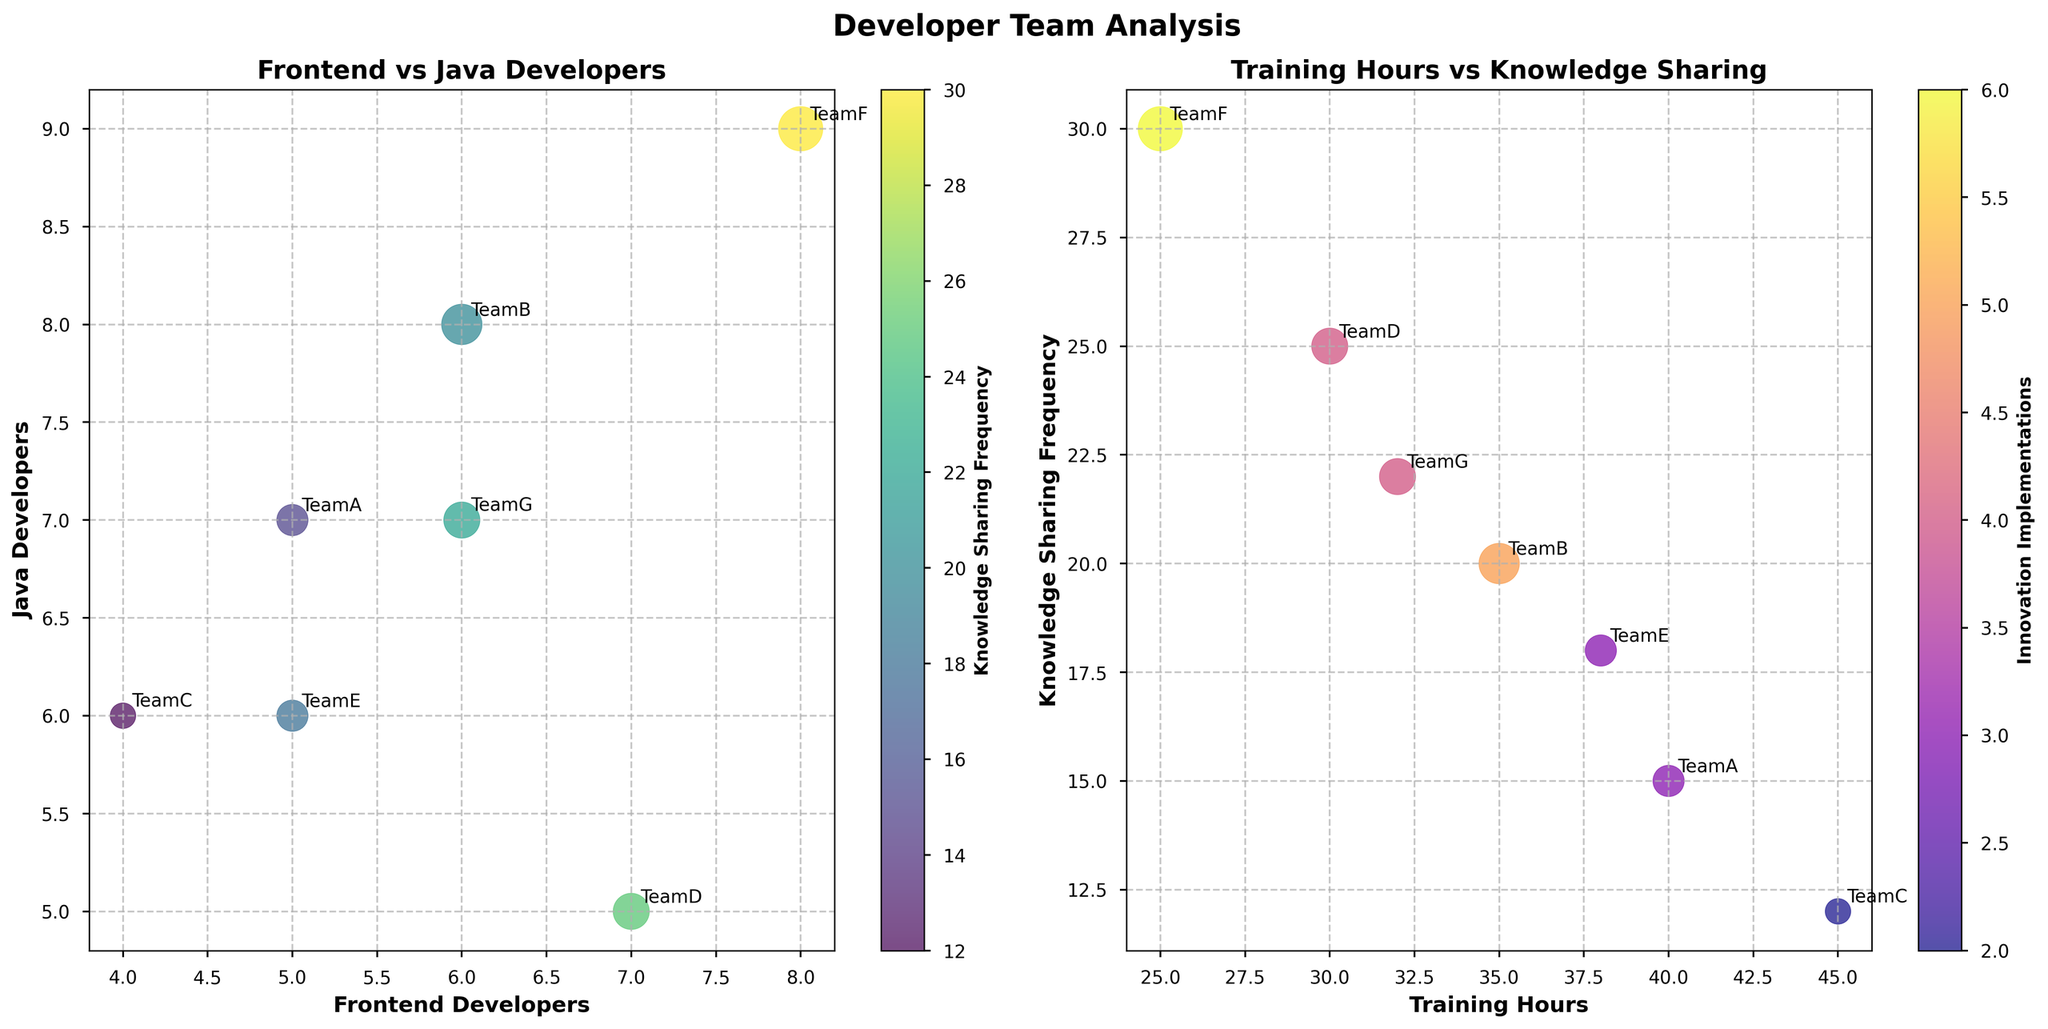What's the title of the first subplot? The title of the first subplot is displayed at the top of the left subplot, it reads "Frontend vs Java Developers".
Answer: Frontend vs Java Developers How many developer teams are included in the plot? The plot includes 7 developer teams, as identified by the annotations near each data point.
Answer: 7 Which team has the highest count of knowledge sharing frequency? The color intensity corresponds to the knowledge sharing frequency. In the first subplot, the team with the darkest color and highest count is TeamF, which has a knowledge sharing frequency of 30.
Answer: TeamF Which team has the highest number of Java Developers? By looking at the x-axis of the first subplot, TeamF has the highest count at 9 developers.
Answer: TeamF What is the relationship between training hours and knowledge sharing frequency in TeamC? TeamC is plotted based on its training hours (45) and knowledge sharing frequency (12) in the second subplot. These coordinates represent the relationship between the two variables.
Answer: 45 training hours, 12 sharing frequency Which team has implemented the most innovations? The size of the bubble indicates the number of innovations implemented. The largest bubble in both subplots represents TeamF, which has implemented 6 innovations.
Answer: TeamF What is the average number of Java Developers across all teams? Add the number of Java Developers for each team (7 + 8 + 6 + 5 + 6 + 9 + 7 = 48) and divide by the number of teams (7). The average is 48/7 ≈ 6.86.
Answer: 6.86 Which team has the most balanced number of Frontend and Java Developers? TeamD has 7 Frontend Developers and 5 Java Developers, which is the closest balance among all teams.
Answer: TeamD Do higher training hours correlate with higher knowledge sharing frequency? By examining the second subplot, teams with higher training hours (e.g., TeamC with 45 hours, TeamA with 40 hours) do not consistently have the highest sharing frequencies. The relationship does not indicate a clear positive correlation.
Answer: No In the context of the second subplot, which teams have the highest and lowest knowledge sharing frequencies? The highest knowledge sharing frequency is represented by the highest y-coordinate, which is TeamF (30). The lowest frequency is represented by the lowest y-coordinate, which is TeamC (12).
Answer: Highest: TeamF, Lowest: TeamC 